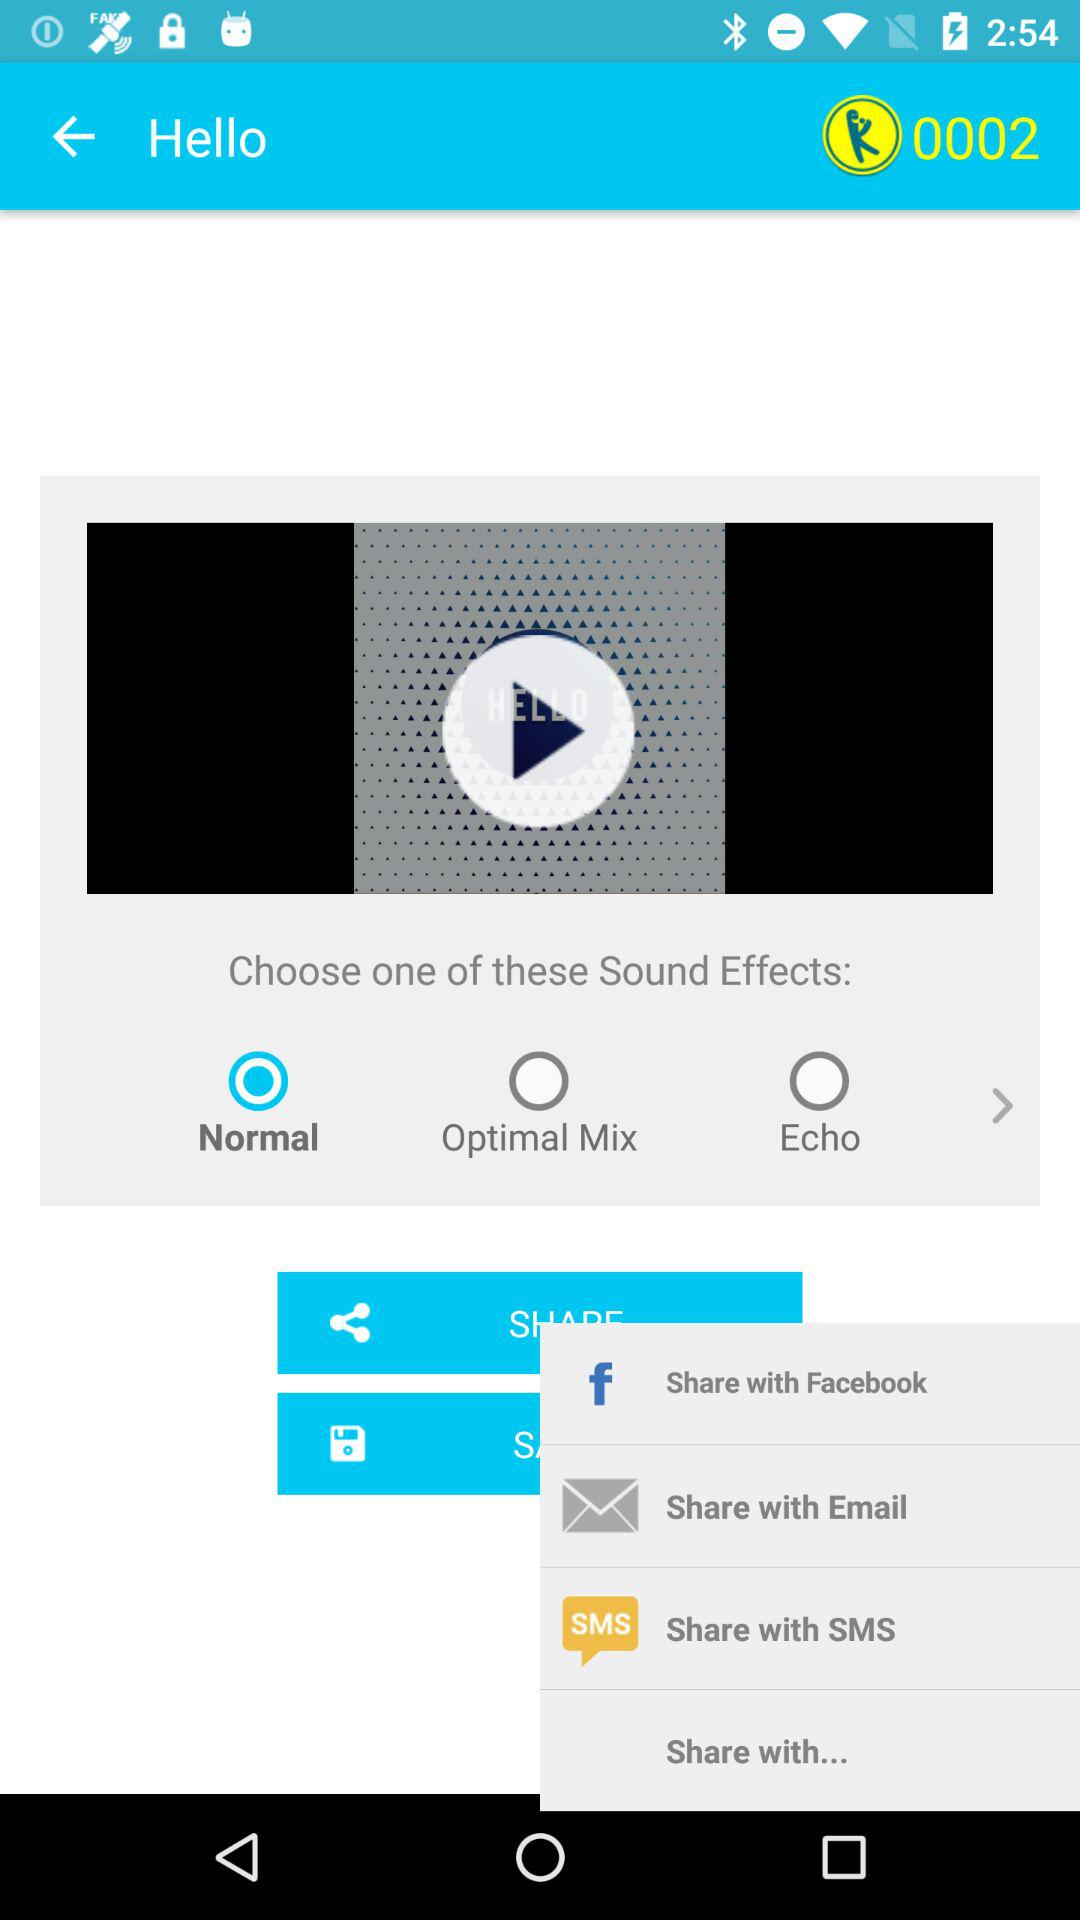How many options are there to choose a sound effect?
Answer the question using a single word or phrase. 3 